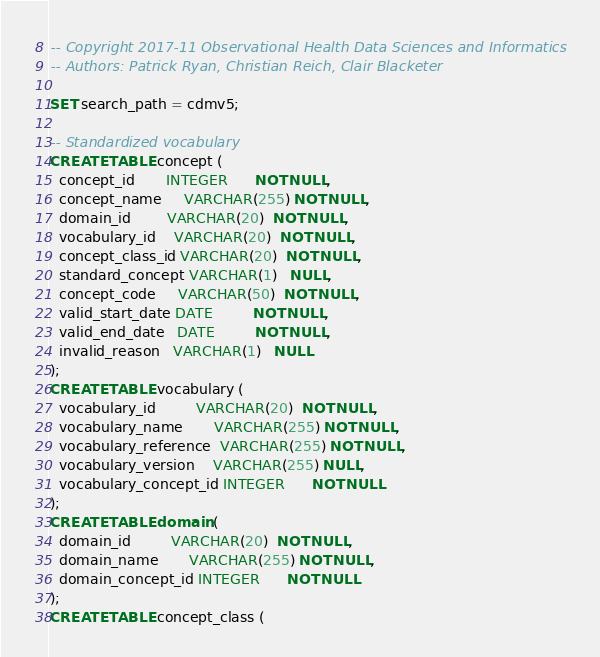Convert code to text. <code><loc_0><loc_0><loc_500><loc_500><_SQL_>-- Copyright 2017-11 Observational Health Data Sciences and Informatics
-- Authors: Patrick Ryan, Christian Reich, Clair Blacketer

SET search_path = cdmv5;

-- Standardized vocabulary
CREATE TABLE concept (
  concept_id       INTEGER      NOT NULL,
  concept_name     VARCHAR(255) NOT NULL,
  domain_id        VARCHAR(20)  NOT NULL,
  vocabulary_id    VARCHAR(20)  NOT NULL,
  concept_class_id VARCHAR(20)  NOT NULL,
  standard_concept VARCHAR(1)   NULL,
  concept_code     VARCHAR(50)  NOT NULL,
  valid_start_date DATE         NOT NULL,
  valid_end_date   DATE         NOT NULL,
  invalid_reason   VARCHAR(1)   NULL
);
CREATE TABLE vocabulary (
  vocabulary_id         VARCHAR(20)  NOT NULL,
  vocabulary_name       VARCHAR(255) NOT NULL,
  vocabulary_reference  VARCHAR(255) NOT NULL,
  vocabulary_version    VARCHAR(255) NULL,
  vocabulary_concept_id INTEGER      NOT NULL
);
CREATE TABLE domain (
  domain_id         VARCHAR(20)  NOT NULL,
  domain_name       VARCHAR(255) NOT NULL,
  domain_concept_id INTEGER      NOT NULL
);
CREATE TABLE concept_class (</code> 